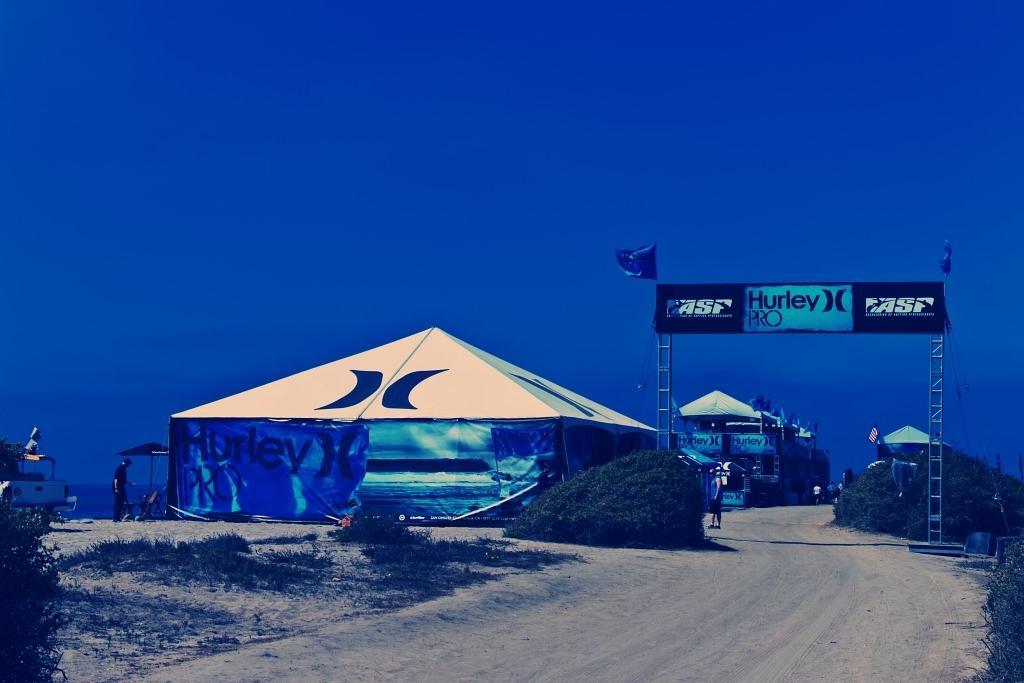Please provide a concise description of this image. In this image, we can see some houses. There are a few people. We can see the ground with an object. We can also see some grass, plants. We can see an arch with poles. There are a few boards with text. We can also see the sky. 